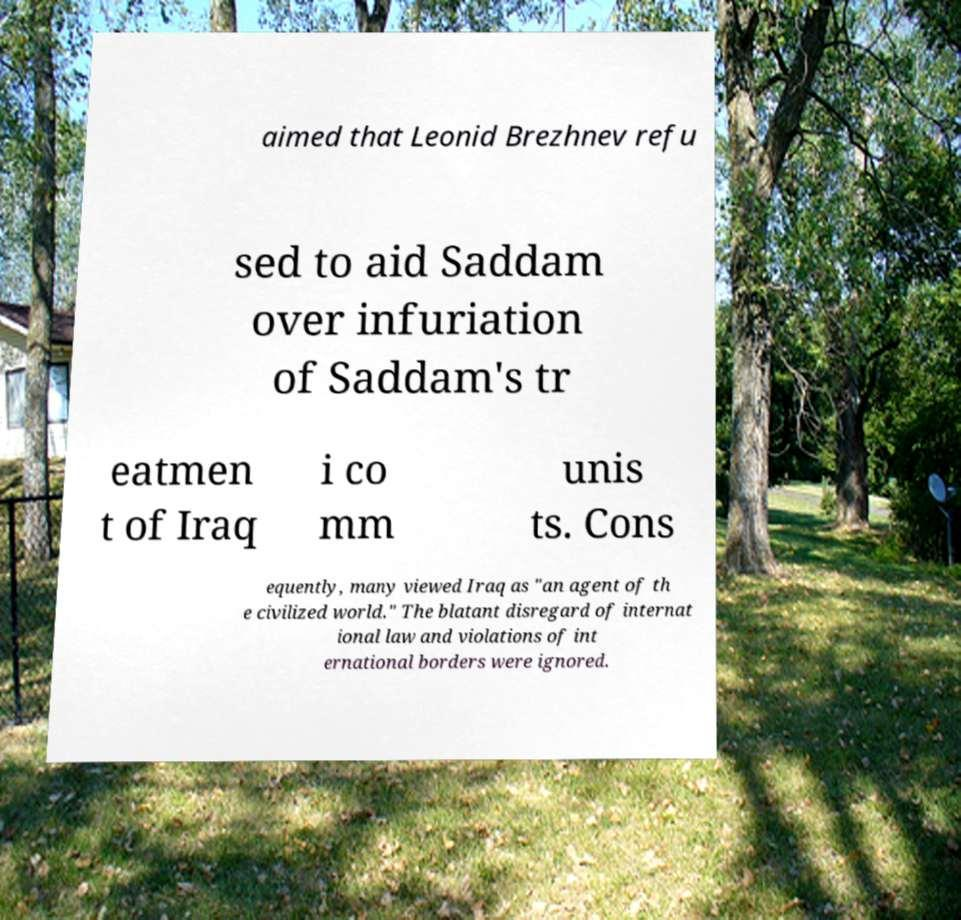Could you assist in decoding the text presented in this image and type it out clearly? aimed that Leonid Brezhnev refu sed to aid Saddam over infuriation of Saddam's tr eatmen t of Iraq i co mm unis ts. Cons equently, many viewed Iraq as "an agent of th e civilized world." The blatant disregard of internat ional law and violations of int ernational borders were ignored. 